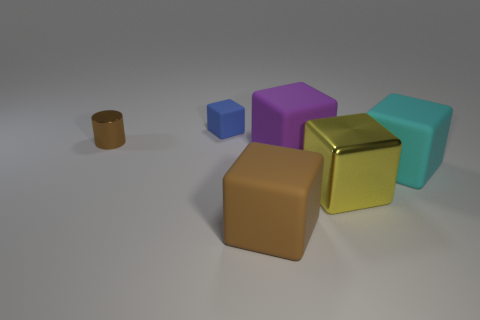Subtract all yellow cubes. How many cubes are left? 4 Subtract 3 cubes. How many cubes are left? 2 Subtract all brown blocks. How many blocks are left? 4 Add 2 small blue shiny balls. How many objects exist? 8 Subtract all red cubes. Subtract all red spheres. How many cubes are left? 5 Subtract all blocks. How many objects are left? 1 Subtract all yellow objects. Subtract all tiny yellow cubes. How many objects are left? 5 Add 6 metallic cylinders. How many metallic cylinders are left? 7 Add 1 small metallic objects. How many small metallic objects exist? 2 Subtract 0 yellow cylinders. How many objects are left? 6 